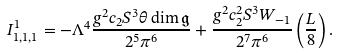Convert formula to latex. <formula><loc_0><loc_0><loc_500><loc_500>I ^ { 1 } _ { 1 , 1 , 1 } = - \Lambda ^ { 4 } \frac { g ^ { 2 } c _ { 2 } S ^ { 3 } \theta \dim \mathfrak { g } } { 2 ^ { 5 } \pi ^ { 6 } } + \frac { g ^ { 2 } c _ { 2 } ^ { 2 } S ^ { 3 } W _ { - 1 } } { 2 ^ { 7 } \pi ^ { 6 } } \left ( \frac { L } { 8 } \right ) .</formula> 